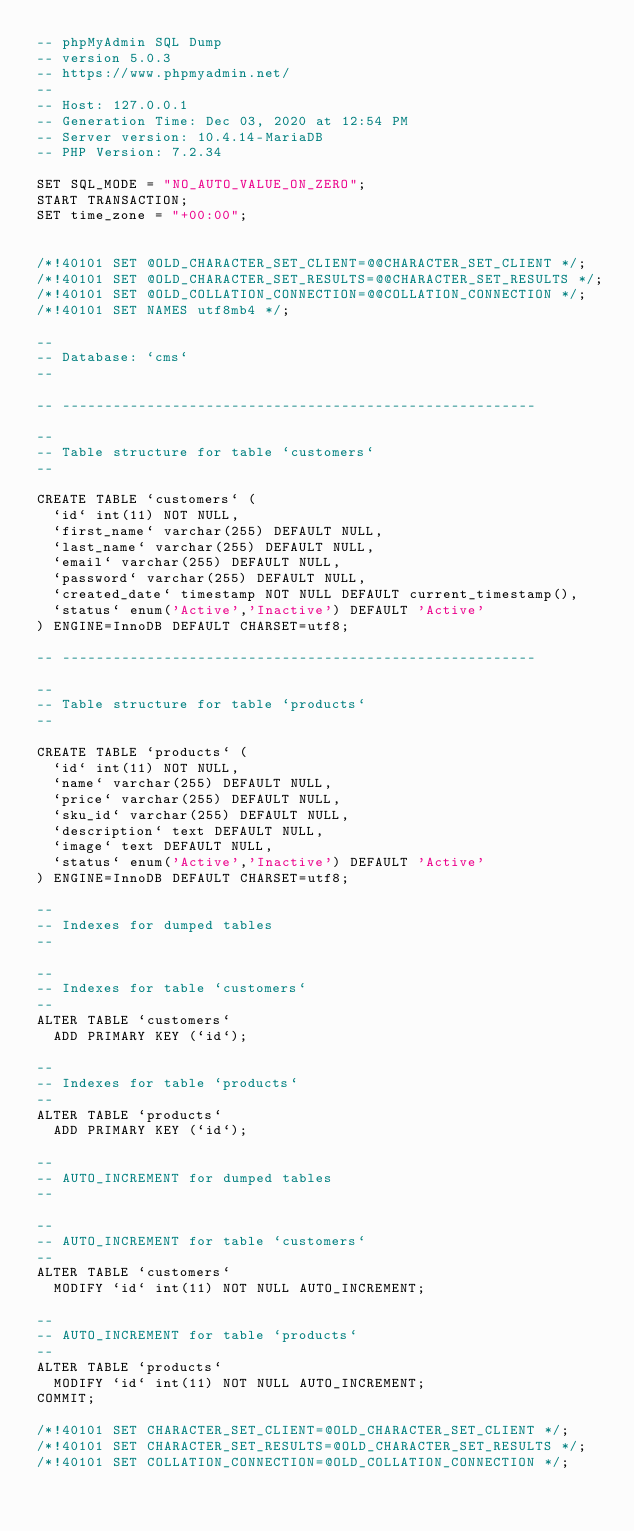Convert code to text. <code><loc_0><loc_0><loc_500><loc_500><_SQL_>-- phpMyAdmin SQL Dump
-- version 5.0.3
-- https://www.phpmyadmin.net/
--
-- Host: 127.0.0.1
-- Generation Time: Dec 03, 2020 at 12:54 PM
-- Server version: 10.4.14-MariaDB
-- PHP Version: 7.2.34

SET SQL_MODE = "NO_AUTO_VALUE_ON_ZERO";
START TRANSACTION;
SET time_zone = "+00:00";


/*!40101 SET @OLD_CHARACTER_SET_CLIENT=@@CHARACTER_SET_CLIENT */;
/*!40101 SET @OLD_CHARACTER_SET_RESULTS=@@CHARACTER_SET_RESULTS */;
/*!40101 SET @OLD_COLLATION_CONNECTION=@@COLLATION_CONNECTION */;
/*!40101 SET NAMES utf8mb4 */;

--
-- Database: `cms`
--

-- --------------------------------------------------------

--
-- Table structure for table `customers`
--

CREATE TABLE `customers` (
  `id` int(11) NOT NULL,
  `first_name` varchar(255) DEFAULT NULL,
  `last_name` varchar(255) DEFAULT NULL,
  `email` varchar(255) DEFAULT NULL,
  `password` varchar(255) DEFAULT NULL,
  `created_date` timestamp NOT NULL DEFAULT current_timestamp(),
  `status` enum('Active','Inactive') DEFAULT 'Active'
) ENGINE=InnoDB DEFAULT CHARSET=utf8;

-- --------------------------------------------------------

--
-- Table structure for table `products`
--

CREATE TABLE `products` (
  `id` int(11) NOT NULL,
  `name` varchar(255) DEFAULT NULL,
  `price` varchar(255) DEFAULT NULL,
  `sku_id` varchar(255) DEFAULT NULL,
  `description` text DEFAULT NULL,
  `image` text DEFAULT NULL,
  `status` enum('Active','Inactive') DEFAULT 'Active'
) ENGINE=InnoDB DEFAULT CHARSET=utf8;

--
-- Indexes for dumped tables
--

--
-- Indexes for table `customers`
--
ALTER TABLE `customers`
  ADD PRIMARY KEY (`id`);

--
-- Indexes for table `products`
--
ALTER TABLE `products`
  ADD PRIMARY KEY (`id`);

--
-- AUTO_INCREMENT for dumped tables
--

--
-- AUTO_INCREMENT for table `customers`
--
ALTER TABLE `customers`
  MODIFY `id` int(11) NOT NULL AUTO_INCREMENT;

--
-- AUTO_INCREMENT for table `products`
--
ALTER TABLE `products`
  MODIFY `id` int(11) NOT NULL AUTO_INCREMENT;
COMMIT;

/*!40101 SET CHARACTER_SET_CLIENT=@OLD_CHARACTER_SET_CLIENT */;
/*!40101 SET CHARACTER_SET_RESULTS=@OLD_CHARACTER_SET_RESULTS */;
/*!40101 SET COLLATION_CONNECTION=@OLD_COLLATION_CONNECTION */;
</code> 